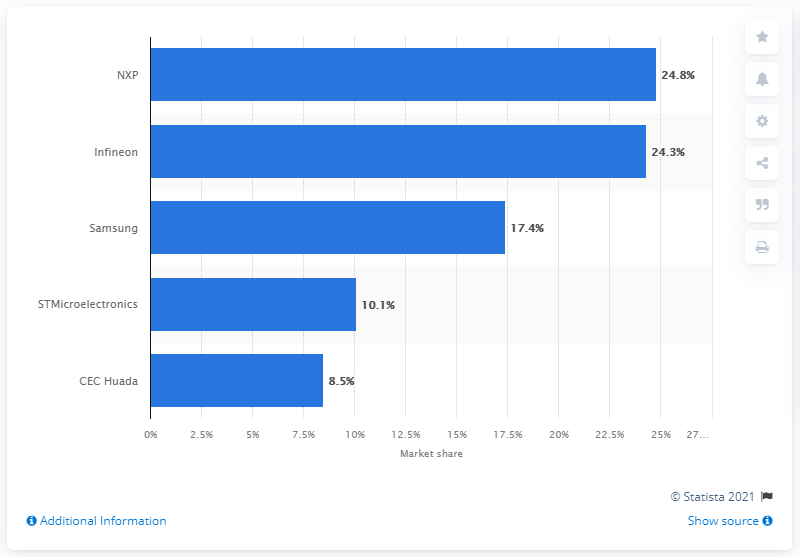Specify some key components in this picture. In 2018, Infineon held a market share of 24.3% in the global microcontroller-based chip card ICs market. 